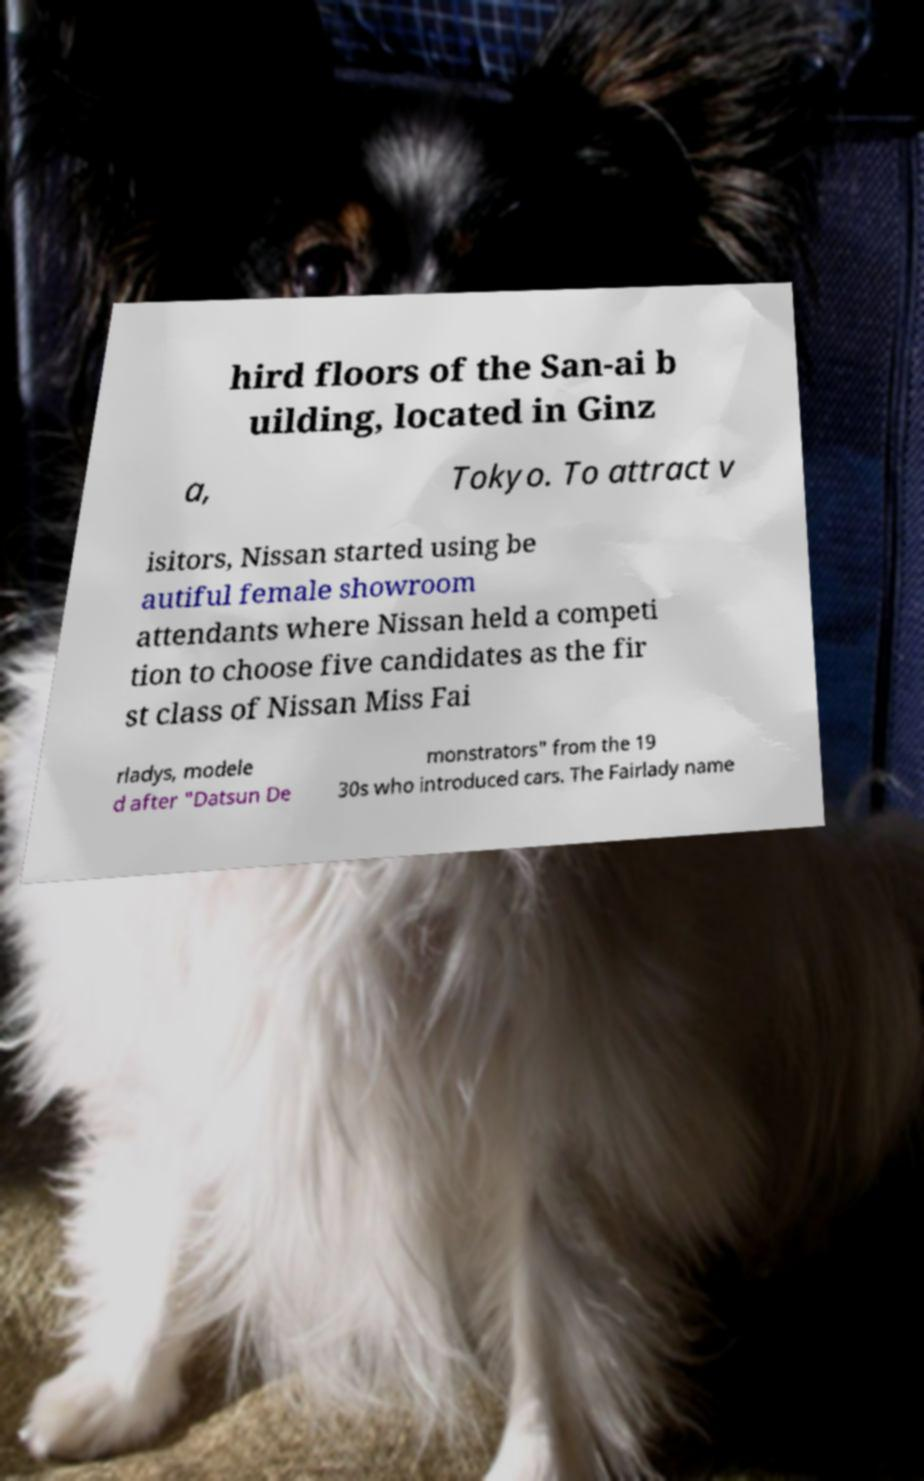Could you extract and type out the text from this image? hird floors of the San-ai b uilding, located in Ginz a, Tokyo. To attract v isitors, Nissan started using be autiful female showroom attendants where Nissan held a competi tion to choose five candidates as the fir st class of Nissan Miss Fai rladys, modele d after "Datsun De monstrators" from the 19 30s who introduced cars. The Fairlady name 